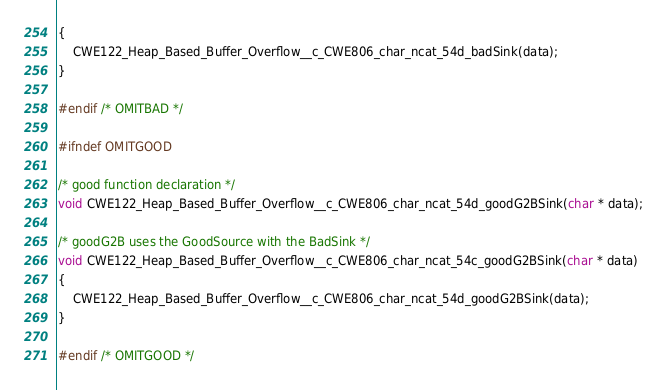<code> <loc_0><loc_0><loc_500><loc_500><_C_>{
    CWE122_Heap_Based_Buffer_Overflow__c_CWE806_char_ncat_54d_badSink(data);
}

#endif /* OMITBAD */

#ifndef OMITGOOD

/* good function declaration */
void CWE122_Heap_Based_Buffer_Overflow__c_CWE806_char_ncat_54d_goodG2BSink(char * data);

/* goodG2B uses the GoodSource with the BadSink */
void CWE122_Heap_Based_Buffer_Overflow__c_CWE806_char_ncat_54c_goodG2BSink(char * data)
{
    CWE122_Heap_Based_Buffer_Overflow__c_CWE806_char_ncat_54d_goodG2BSink(data);
}

#endif /* OMITGOOD */
</code> 